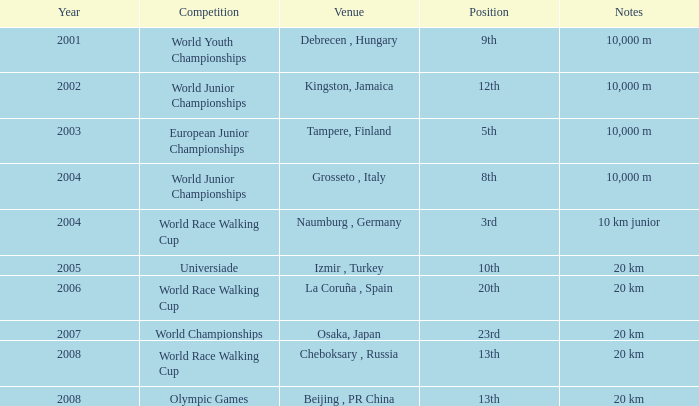In which year was he a competitor in the universiade? 2005.0. 